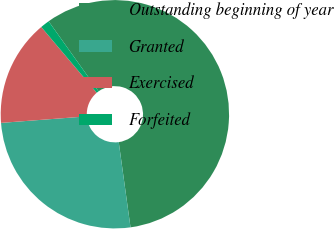<chart> <loc_0><loc_0><loc_500><loc_500><pie_chart><fcel>Outstanding beginning of year<fcel>Granted<fcel>Exercised<fcel>Forfeited<nl><fcel>57.67%<fcel>25.98%<fcel>15.05%<fcel>1.3%<nl></chart> 